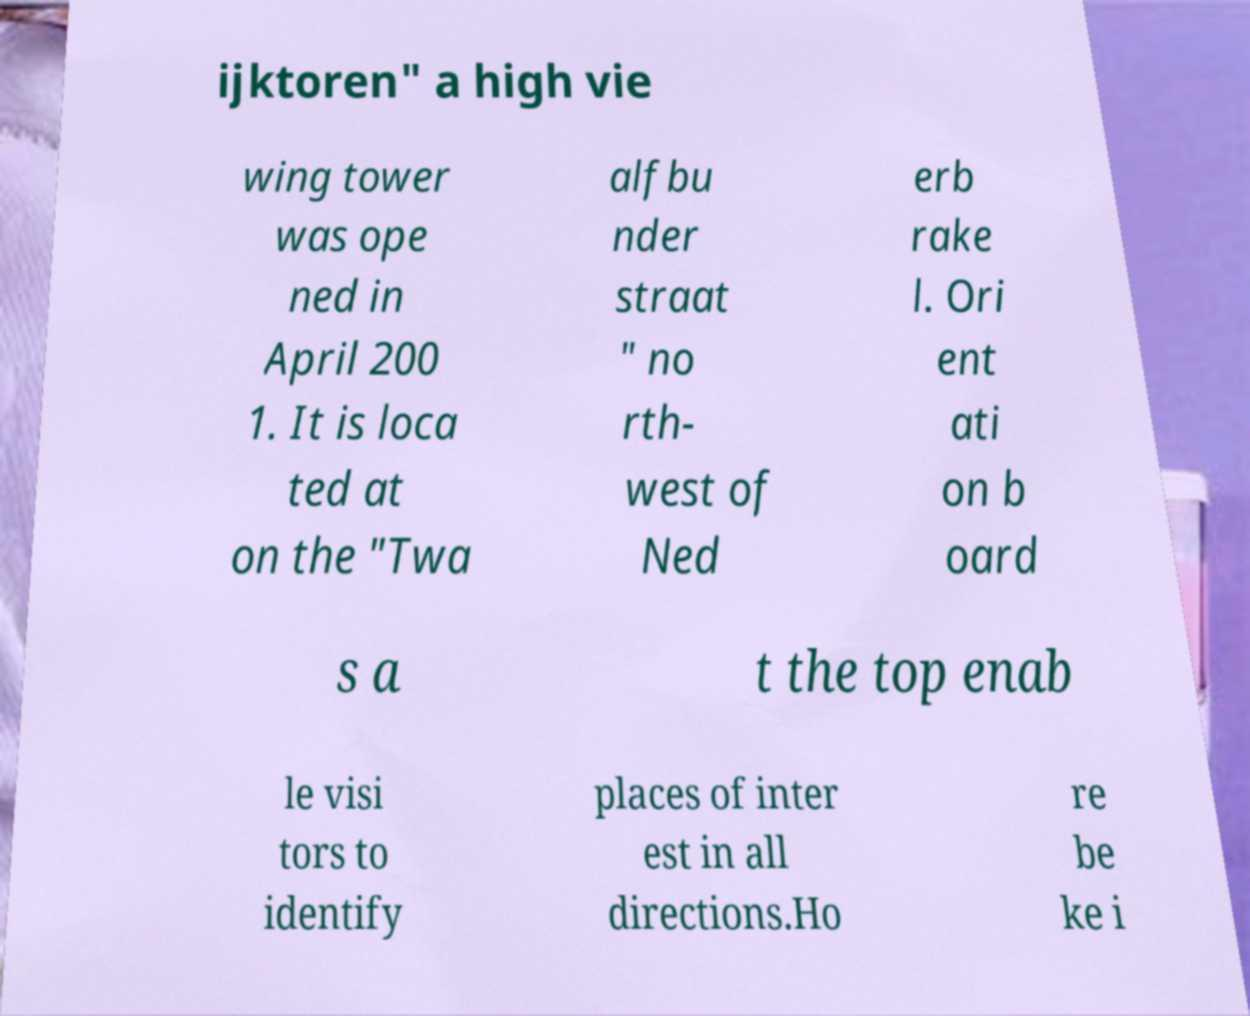Please read and relay the text visible in this image. What does it say? ijktoren" a high vie wing tower was ope ned in April 200 1. It is loca ted at on the "Twa alfbu nder straat " no rth- west of Ned erb rake l. Ori ent ati on b oard s a t the top enab le visi tors to identify places of inter est in all directions.Ho re be ke i 